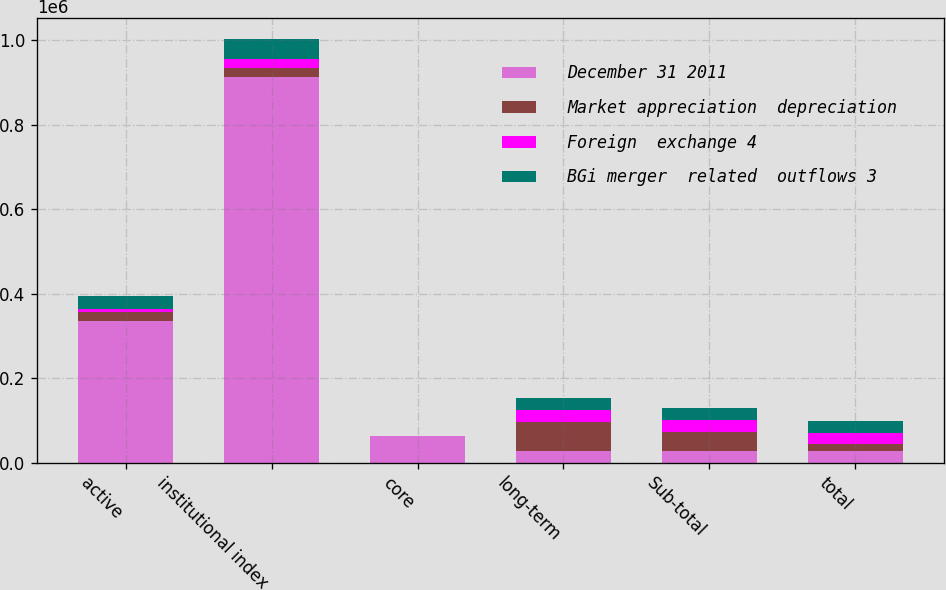Convert chart. <chart><loc_0><loc_0><loc_500><loc_500><stacked_bar_chart><ecel><fcel>active<fcel>institutional index<fcel>core<fcel>long-term<fcel>Sub-total<fcel>total<nl><fcel>December 31 2011<fcel>334532<fcel>911775<fcel>63603<fcel>28251<fcel>28251<fcel>28251<nl><fcel>Market appreciation  depreciation<fcel>22876<fcel>22403<fcel>48<fcel>67349<fcel>44450<fcel>14547<nl><fcel>Foreign  exchange 4<fcel>6943<fcel>20630<fcel>152<fcel>28251<fcel>28251<fcel>28251<nl><fcel>BGi merger  related  outflows 3<fcel>29793<fcel>48402<fcel>179<fcel>29089<fcel>28961<fcel>27513<nl></chart> 